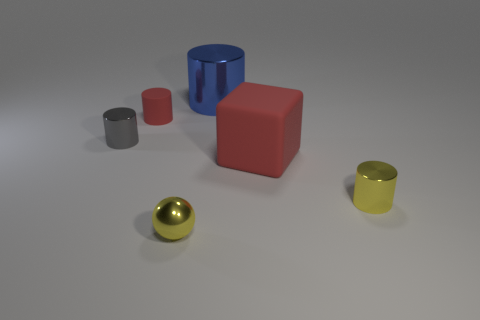The small yellow thing that is made of the same material as the yellow cylinder is what shape?
Provide a succinct answer. Sphere. What color is the tiny shiny cylinder that is on the right side of the red matte thing in front of the small gray metallic thing?
Provide a short and direct response. Yellow. Is the rubber cylinder the same color as the large metallic cylinder?
Make the answer very short. No. What is the material of the tiny object that is in front of the tiny yellow metallic thing right of the sphere?
Provide a short and direct response. Metal. There is a large object that is the same shape as the small rubber thing; what is its material?
Your answer should be compact. Metal. Are there any big cylinders to the right of the blue shiny cylinder that is behind the yellow object that is on the right side of the large metallic thing?
Make the answer very short. No. How many other objects are there of the same color as the large rubber object?
Your answer should be very brief. 1. How many cylinders are both on the left side of the yellow ball and behind the red matte cylinder?
Provide a short and direct response. 0. The big red thing has what shape?
Keep it short and to the point. Cube. How many other objects are there of the same material as the blue object?
Your answer should be very brief. 3. 